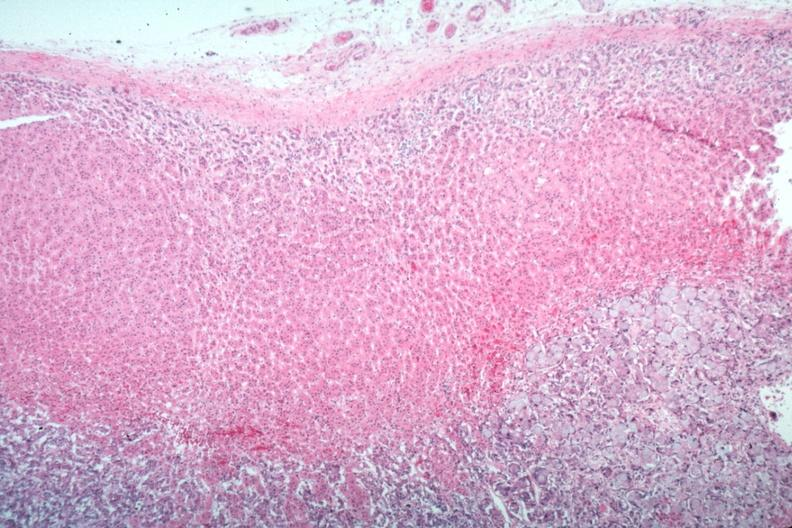s adrenal present?
Answer the question using a single word or phrase. Yes 